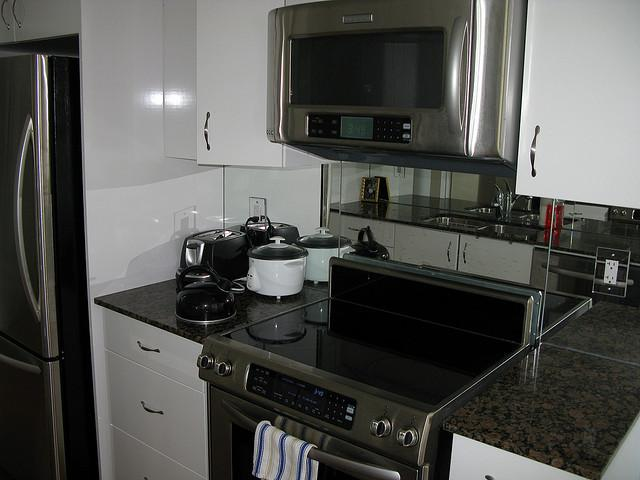What is the white cooker called? Please explain your reasoning. rice cooker. The small bowl with a lid is called the rice cooker. 